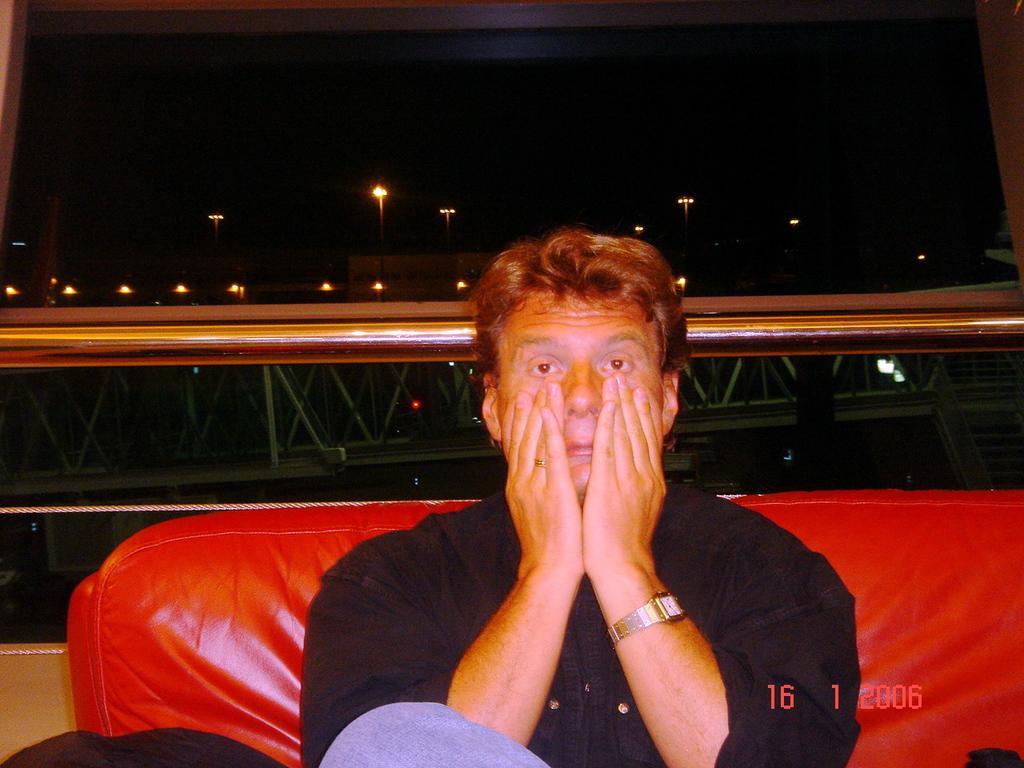In one or two sentences, can you explain what this image depicts? In this image there is a person sitting on the couch , and in the background there are iron rods, lights,sky and a watermark on the image. 